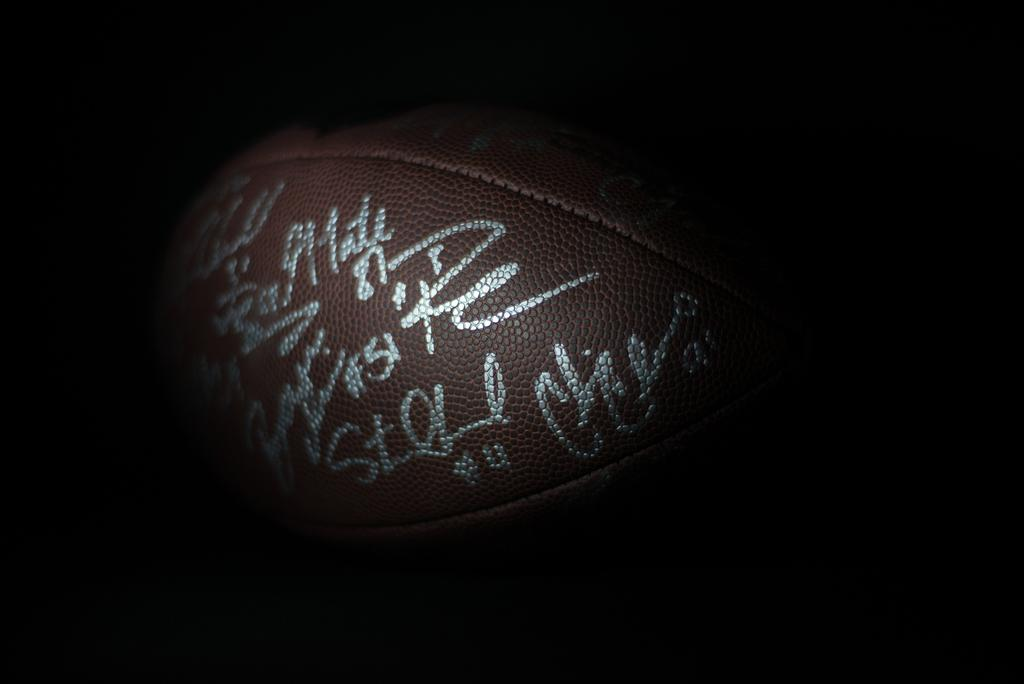What object is present in the image? There is a ball in the image. What feature does the ball have? The ball has text on it. Is there any smoke coming from the ball in the image? No, there is no smoke present in the image; it only features a ball with text on it. 